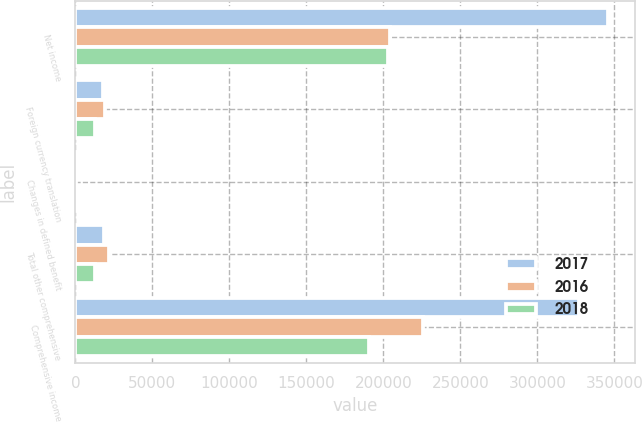<chart> <loc_0><loc_0><loc_500><loc_500><stacked_bar_chart><ecel><fcel>Net income<fcel>Foreign currency translation<fcel>Changes in defined benefit<fcel>Total other comprehensive<fcel>Comprehensive income<nl><fcel>2017<fcel>345777<fcel>17885<fcel>627<fcel>18512<fcel>327265<nl><fcel>2016<fcel>204101<fcel>19394<fcel>424<fcel>21530<fcel>225631<nl><fcel>2018<fcel>203086<fcel>12801<fcel>650<fcel>12735<fcel>190351<nl></chart> 